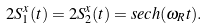<formula> <loc_0><loc_0><loc_500><loc_500>2 S _ { 1 } ^ { x } ( t ) = 2 S _ { 2 } ^ { x } ( t ) = s e c h ( \omega _ { R } t ) .</formula> 